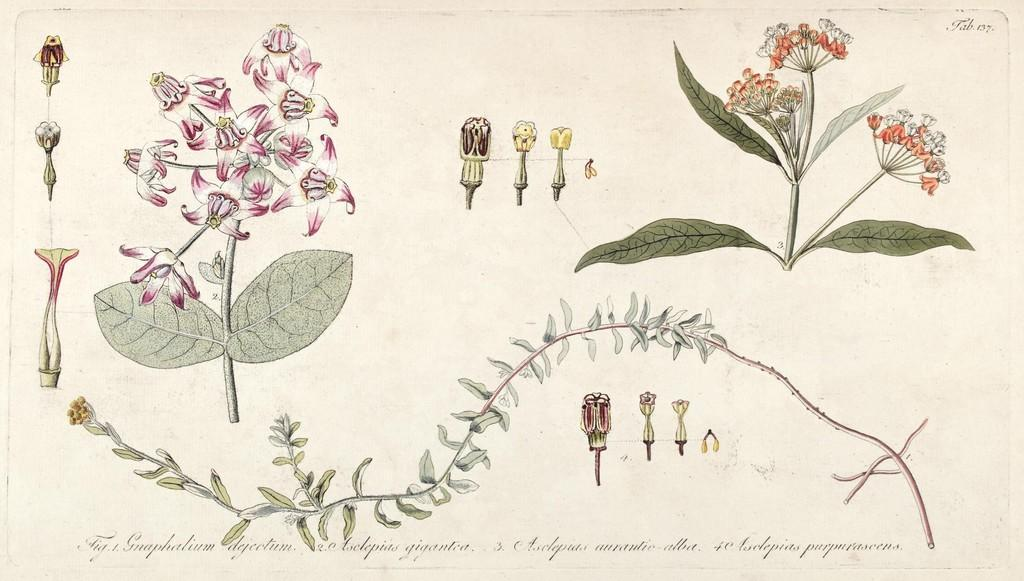What is the main subject of the image? The main subject of the image is an art of flowers. Are the flowers part of a living organism? Yes, the flowers are associated with a plant. What else can be seen in the image besides the flowers? The image includes parts of the plant. Is there any text in the image? Yes, there is edited text at the bottom of the image. What type of sweater is being worn by the leg in the image? There is no sweater or leg present in the image; it features an art of flowers and parts of a plant. 